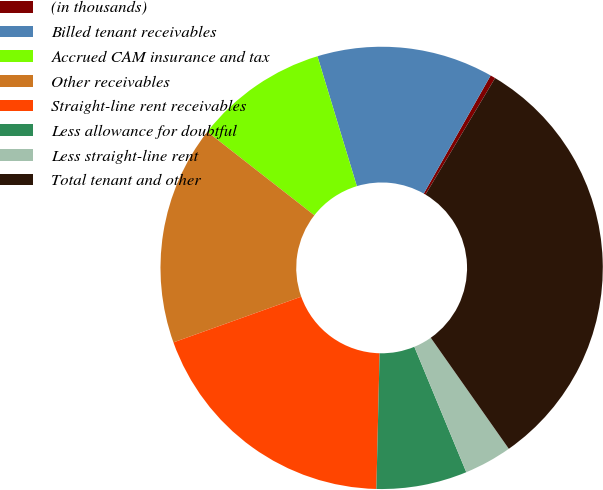Convert chart to OTSL. <chart><loc_0><loc_0><loc_500><loc_500><pie_chart><fcel>(in thousands)<fcel>Billed tenant receivables<fcel>Accrued CAM insurance and tax<fcel>Other receivables<fcel>Straight-line rent receivables<fcel>Less allowance for doubtful<fcel>Less straight-line rent<fcel>Total tenant and other<nl><fcel>0.37%<fcel>12.89%<fcel>9.76%<fcel>16.02%<fcel>19.15%<fcel>6.63%<fcel>3.5%<fcel>31.67%<nl></chart> 